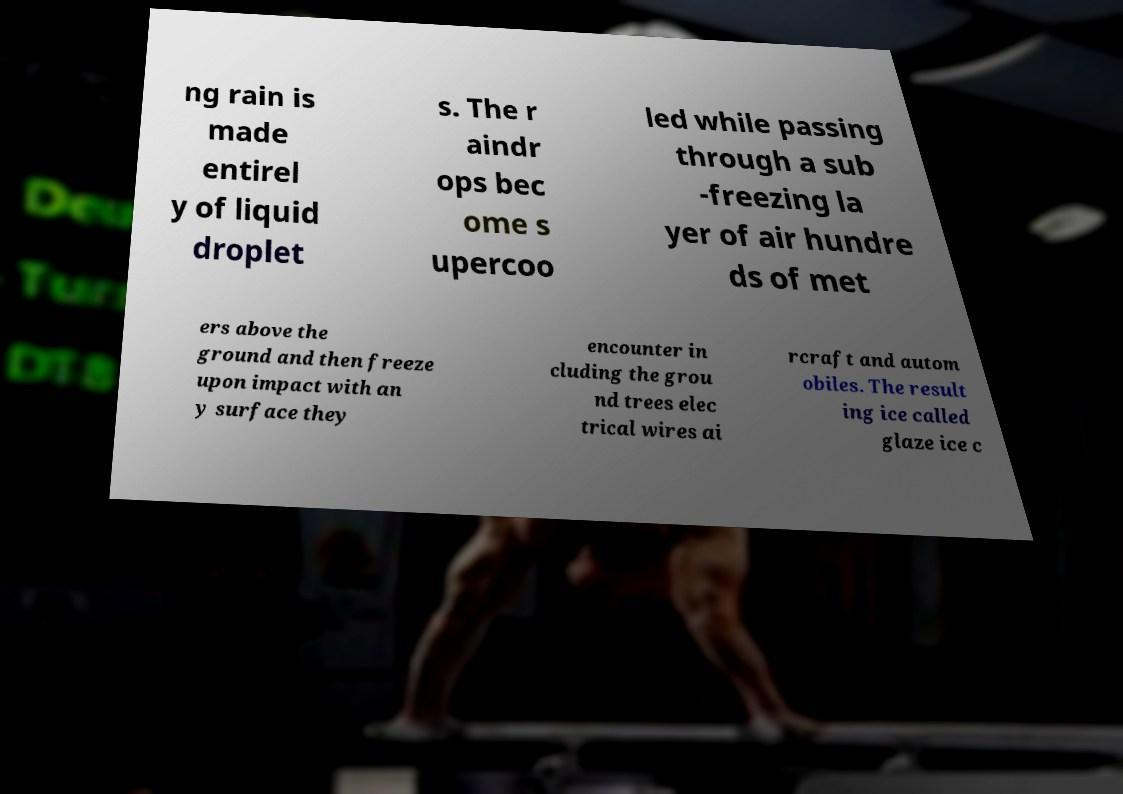Could you assist in decoding the text presented in this image and type it out clearly? ng rain is made entirel y of liquid droplet s. The r aindr ops bec ome s upercoo led while passing through a sub -freezing la yer of air hundre ds of met ers above the ground and then freeze upon impact with an y surface they encounter in cluding the grou nd trees elec trical wires ai rcraft and autom obiles. The result ing ice called glaze ice c 